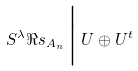Convert formula to latex. <formula><loc_0><loc_0><loc_500><loc_500>S ^ { \lambda } \Re s _ { A _ { n } } \, \Big | \, U \oplus U ^ { t }</formula> 